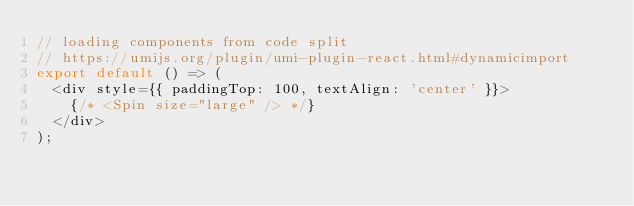Convert code to text. <code><loc_0><loc_0><loc_500><loc_500><_JavaScript_>// loading components from code split
// https://umijs.org/plugin/umi-plugin-react.html#dynamicimport
export default () => (
  <div style={{ paddingTop: 100, textAlign: 'center' }}>
    {/* <Spin size="large" /> */}
  </div>
);
</code> 